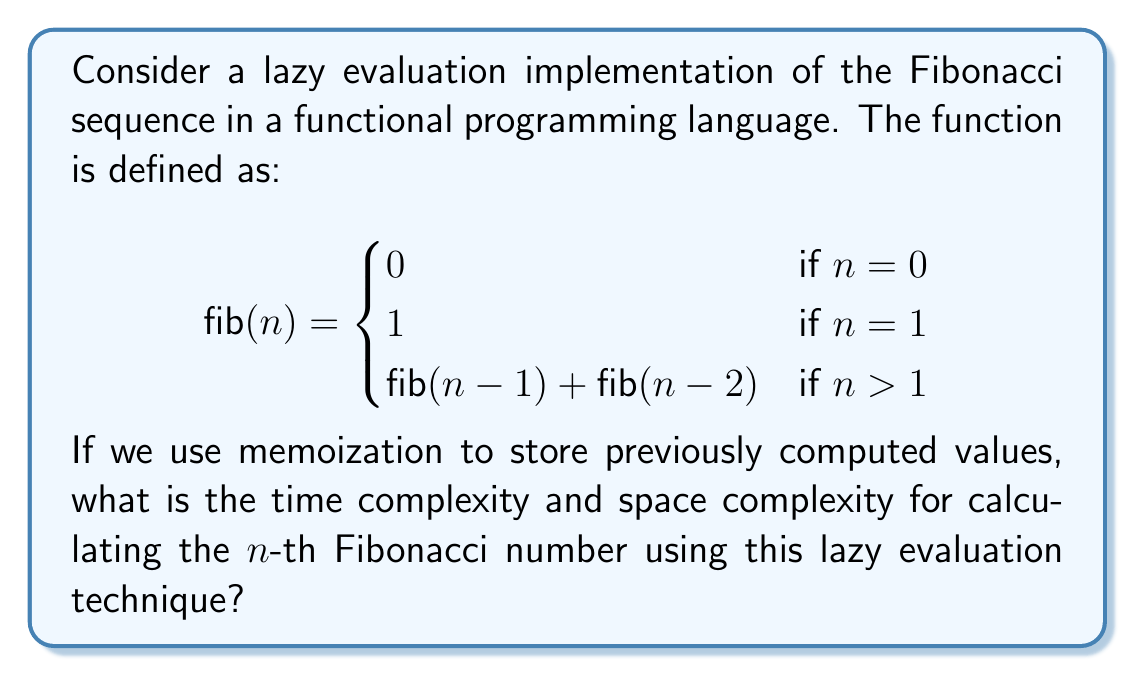Provide a solution to this math problem. Let's analyze the time and space complexity step by step:

1. Time Complexity:
   - In a naive recursive implementation, the time complexity would be $O(2^n)$ due to redundant calculations.
   - However, with lazy evaluation and memoization, each Fibonacci number is computed only once.
   - To compute the $n$-th Fibonacci number, we need to calculate all previous Fibonacci numbers up to $n$.
   - This results in $n$ additions and $n$ memory lookups.
   - Therefore, the time complexity is $O(n)$.

2. Space Complexity:
   - With memoization, we store each computed Fibonacci number.
   - We need to store all Fibonacci numbers from $0$ to $n$.
   - This requires $n+1$ entries in our memoization table.
   - Each entry stores an integer, which typically takes constant space.
   - Thus, the space complexity is $O(n)$.

3. Trade-offs:
   - Time-Space Trade-off: We sacrifice space to gain time efficiency.
   - By using $O(n)$ space for memoization, we reduce the time complexity from exponential $O(2^n)$ to linear $O(n)$.
   - This trade-off is particularly beneficial for functional programming paradigms, where immutability and referential transparency are prioritized.

4. Lazy Evaluation Benefits:
   - Lazy evaluation ensures that Fibonacci numbers are only computed when needed.
   - If we only need a subset of the first $n$ Fibonacci numbers, we avoid unnecessary computations.
   - This can lead to further time savings in practical applications.

5. Kotlin Implementation Consideration:
   - In Kotlin, we can implement this using a lazy sequence, which aligns well with functional programming principles.
   - The sequence would only compute values as they are requested, maintaining the lazy evaluation property.
Answer: Time Complexity: $O(n)$
Space Complexity: $O(n)$ 